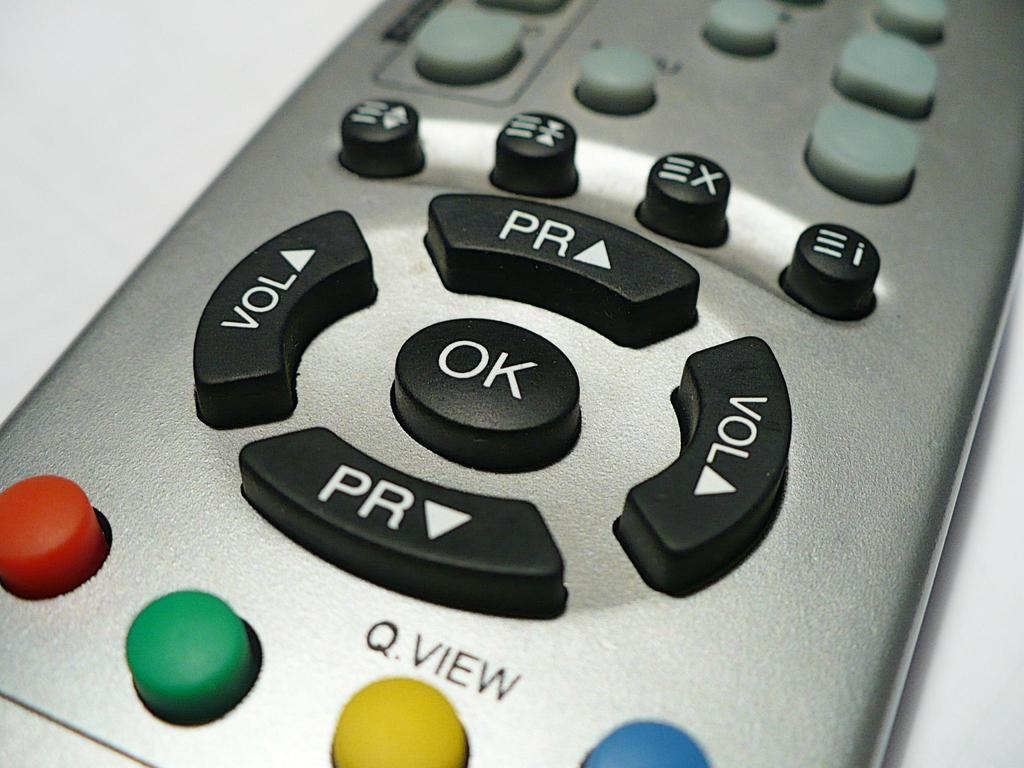<image>
Create a compact narrative representing the image presented. Silver remote that works for a television or cable 